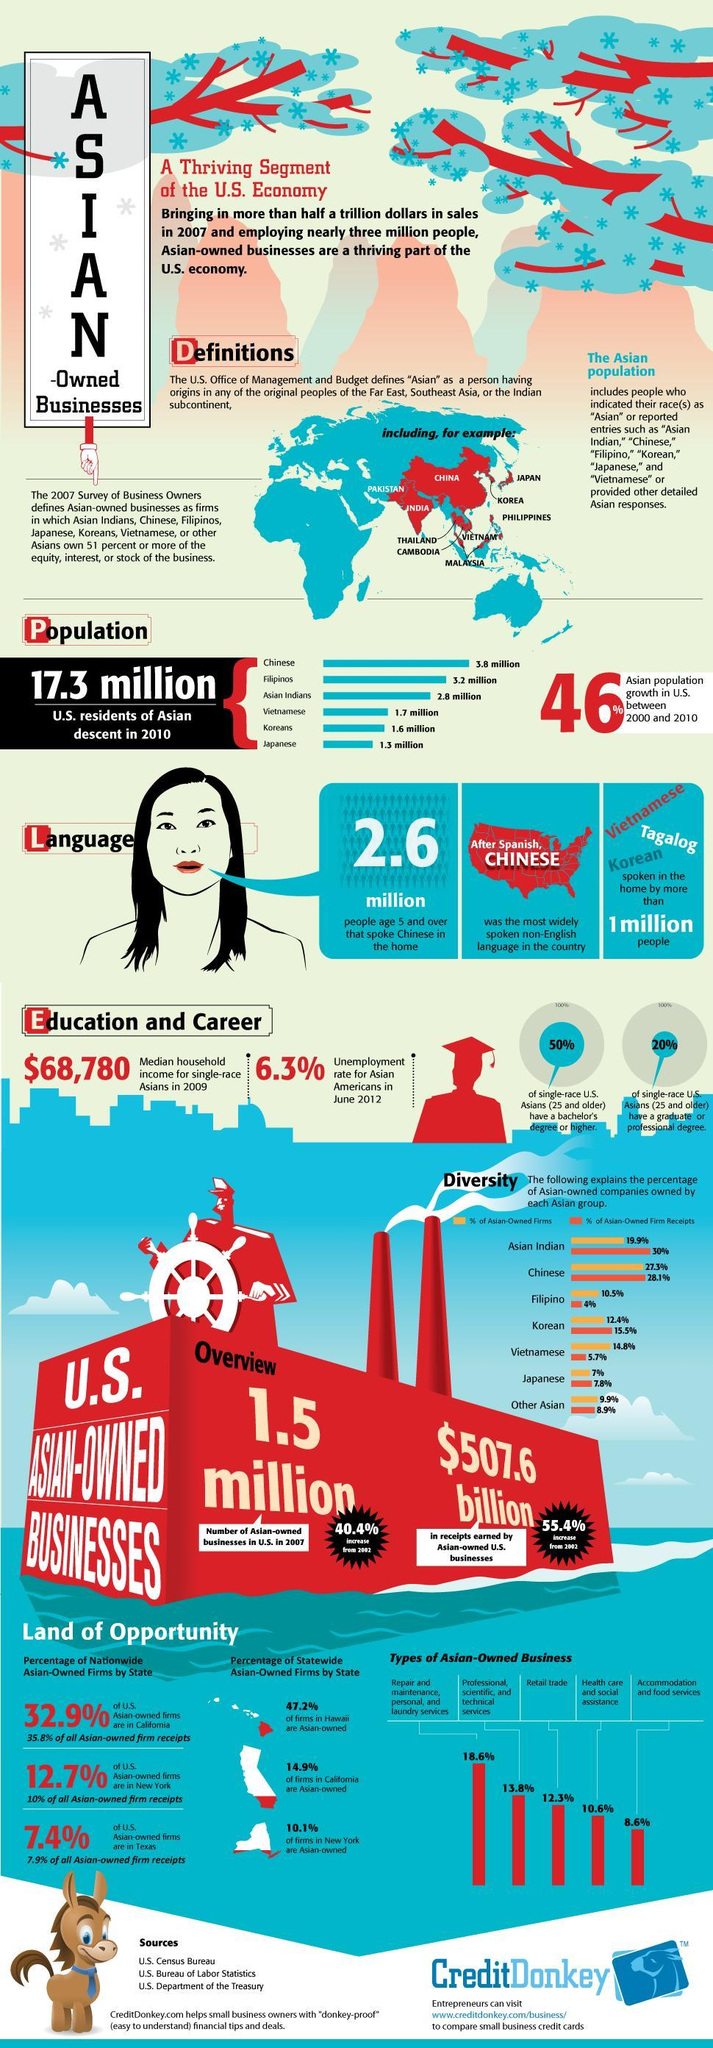How many different types of Asian owned business in U. S are listed?
Answer the question with a short phrase. 5 What percentage of firms in NewYork are not owned by Asians? 89.9 Which type of Asian owned business in U.S has the second highest number? Professional, scientific, and technical services How many Asian countries have their population more than 1.7 million in U.S? 3 Which Asian country has the third largest population in U.S? Asian Indians What percentage of U.S Asian owned firms are in California? 32.9% What percentage of U.S Asian owned firms are in NewYork? 12.7% People of which country has the second largest population in U.S? Filipinos What percentage of U.S Asian owned firms are in Texas? 7.4% What percentage of firms in California are not owned by Asians? 85.1 